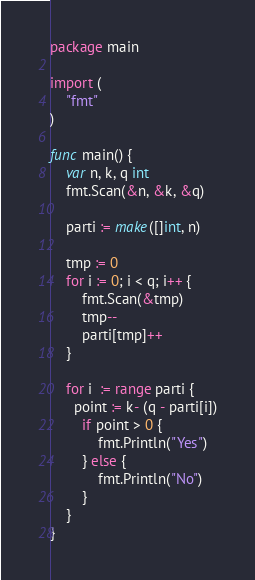Convert code to text. <code><loc_0><loc_0><loc_500><loc_500><_Go_>package main

import (
	"fmt"
)

func main() {
	var n, k, q int
	fmt.Scan(&n, &k, &q)
	
	parti := make([]int, n)
	
	tmp := 0
	for i := 0; i < q; i++ {
		fmt.Scan(&tmp)
		tmp--
		parti[tmp]++
	}

	for i  := range parti {
      point := k- (q - parti[i])
		if point > 0 {
			fmt.Println("Yes")
		} else {
			fmt.Println("No")
		}
	}
}
</code> 